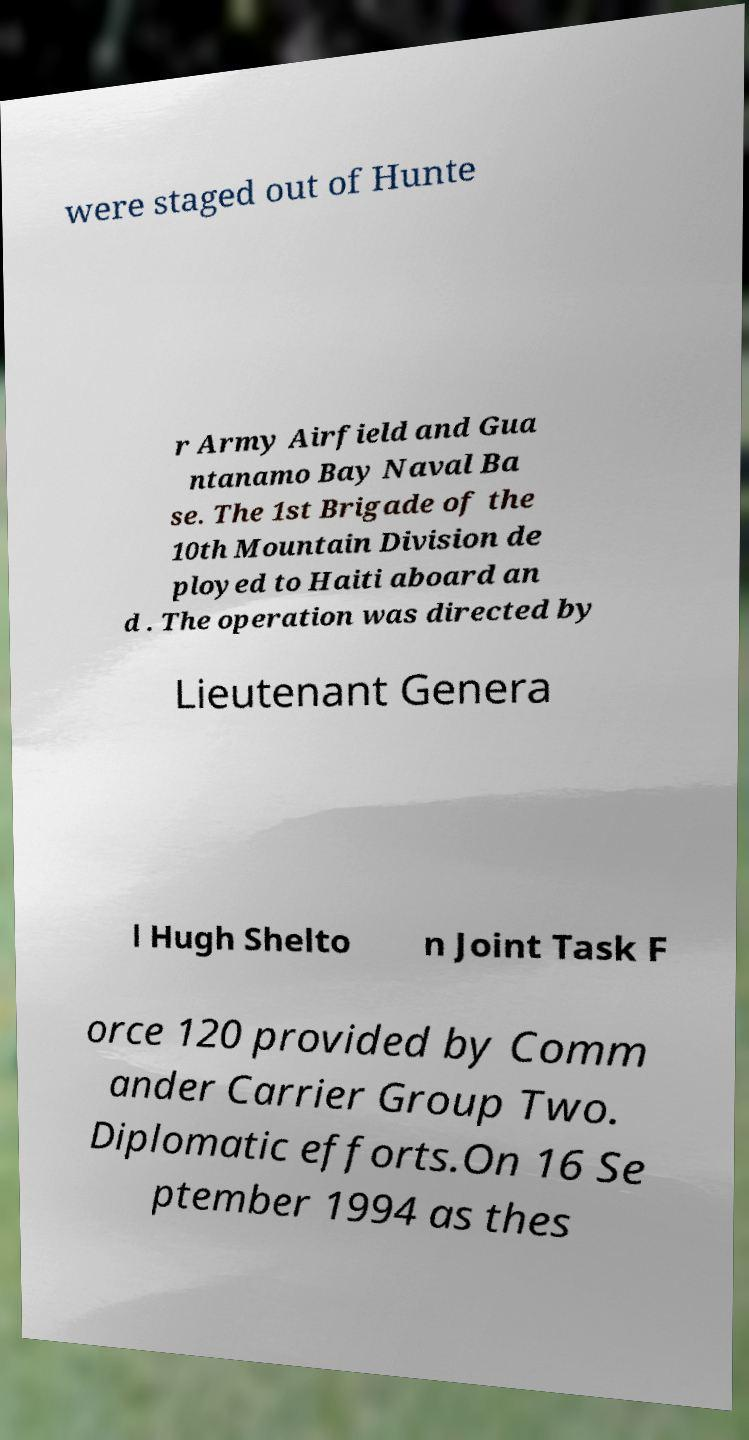Could you assist in decoding the text presented in this image and type it out clearly? were staged out of Hunte r Army Airfield and Gua ntanamo Bay Naval Ba se. The 1st Brigade of the 10th Mountain Division de ployed to Haiti aboard an d . The operation was directed by Lieutenant Genera l Hugh Shelto n Joint Task F orce 120 provided by Comm ander Carrier Group Two. Diplomatic efforts.On 16 Se ptember 1994 as thes 